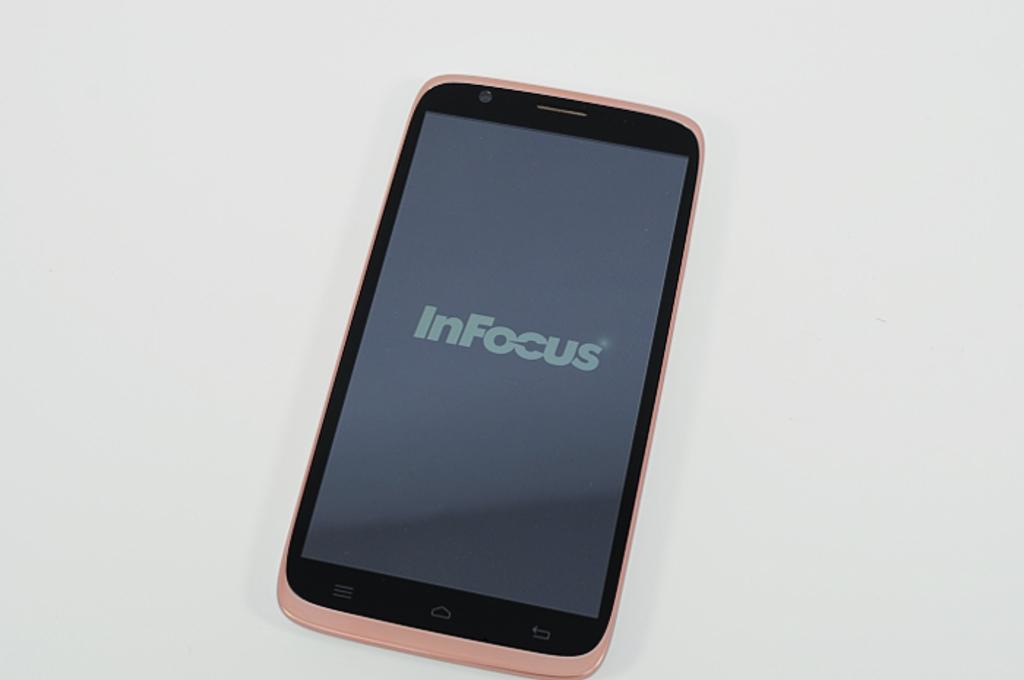What is the make of the phone?
Make the answer very short. Infocus. 